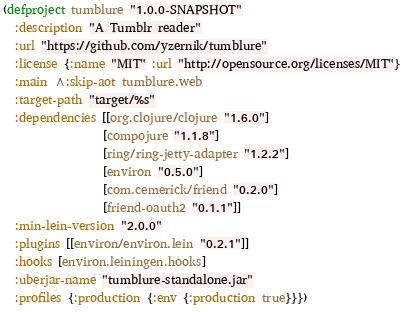<code> <loc_0><loc_0><loc_500><loc_500><_Clojure_>(defproject tumblure "1.0.0-SNAPSHOT"
  :description "A Tumblr reader"
  :url "https://github.com/yzernik/tumblure"
  :license {:name "MIT" :url "http://opensource.org/licenses/MIT"}
  :main ^:skip-aot tumblure.web
  :target-path "target/%s"
  :dependencies [[org.clojure/clojure "1.6.0"]
                 [compojure "1.1.8"]
                 [ring/ring-jetty-adapter "1.2.2"]
                 [environ "0.5.0"]
                 [com.cemerick/friend "0.2.0"]
                 [friend-oauth2 "0.1.1"]]
  :min-lein-version "2.0.0"
  :plugins [[environ/environ.lein "0.2.1"]]
  :hooks [environ.leiningen.hooks]
  :uberjar-name "tumblure-standalone.jar"
  :profiles {:production {:env {:production true}}})
</code> 